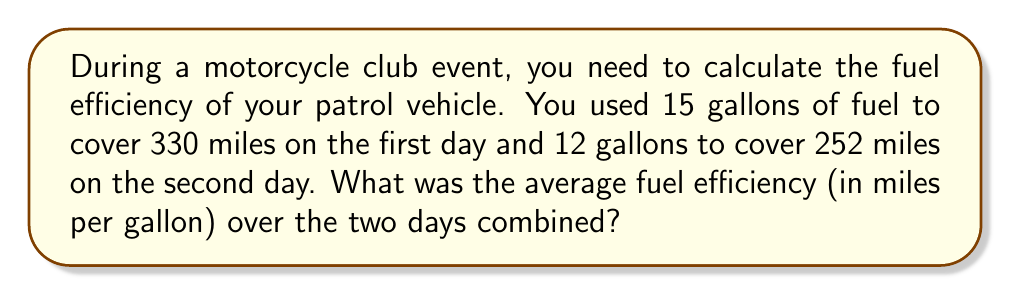Teach me how to tackle this problem. Let's solve this step-by-step:

1. Calculate total distance covered:
   $$ \text{Total distance} = 330 \text{ miles} + 252 \text{ miles} = 582 \text{ miles} $$

2. Calculate total fuel used:
   $$ \text{Total fuel} = 15 \text{ gallons} + 12 \text{ gallons} = 27 \text{ gallons} $$

3. Calculate average fuel efficiency:
   $$ \text{Fuel efficiency} = \frac{\text{Total distance}}{\text{Total fuel}} $$

4. Plug in the values:
   $$ \text{Fuel efficiency} = \frac{582 \text{ miles}}{27 \text{ gallons}} $$

5. Perform the division:
   $$ \text{Fuel efficiency} = 21.5555... \text{ miles per gallon} $$

6. Round to two decimal places:
   $$ \text{Fuel efficiency} \approx 21.56 \text{ miles per gallon} $$
Answer: 21.56 miles per gallon 